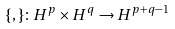<formula> <loc_0><loc_0><loc_500><loc_500>\{ , \} \colon H ^ { p } \times H ^ { q } \to H ^ { p + q - 1 }</formula> 